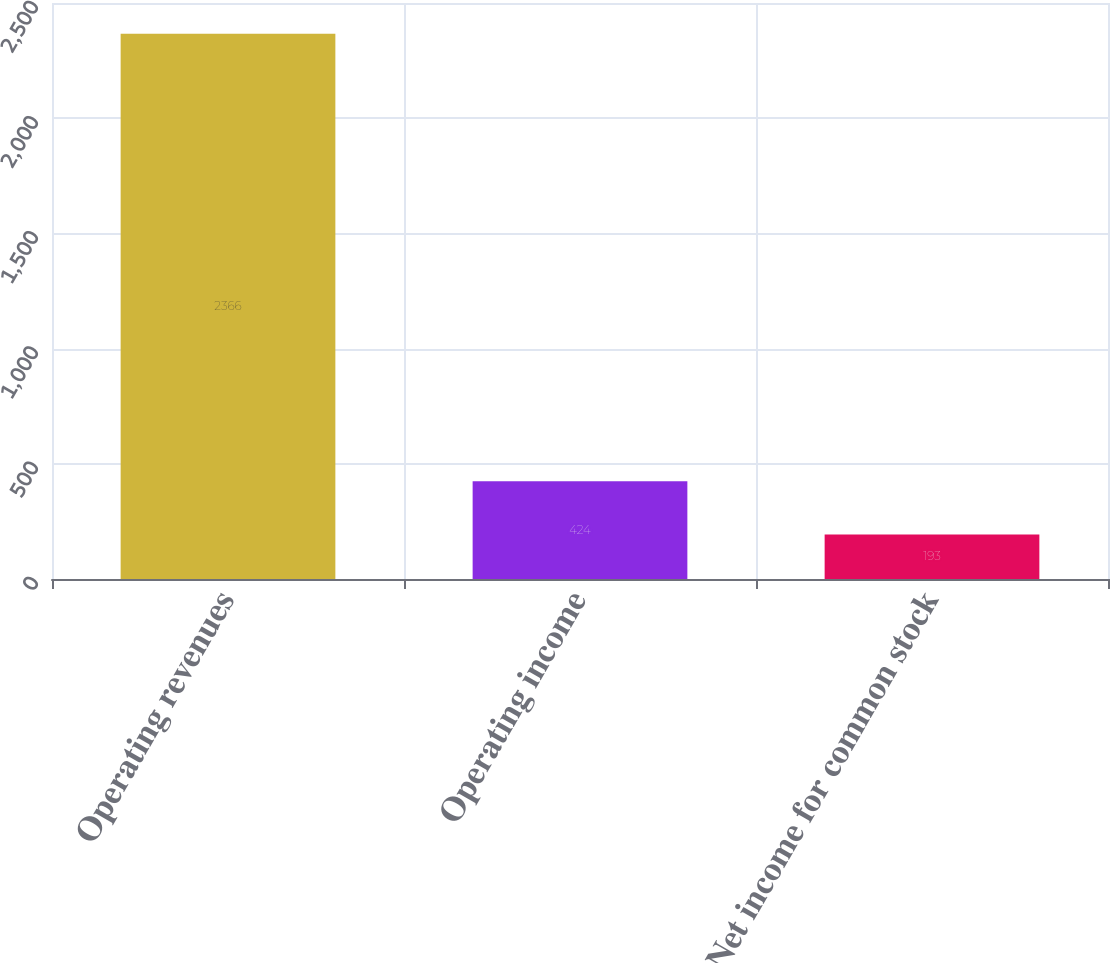Convert chart. <chart><loc_0><loc_0><loc_500><loc_500><bar_chart><fcel>Operating revenues<fcel>Operating income<fcel>Net income for common stock<nl><fcel>2366<fcel>424<fcel>193<nl></chart> 